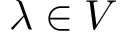Convert formula to latex. <formula><loc_0><loc_0><loc_500><loc_500>\lambda \in V</formula> 